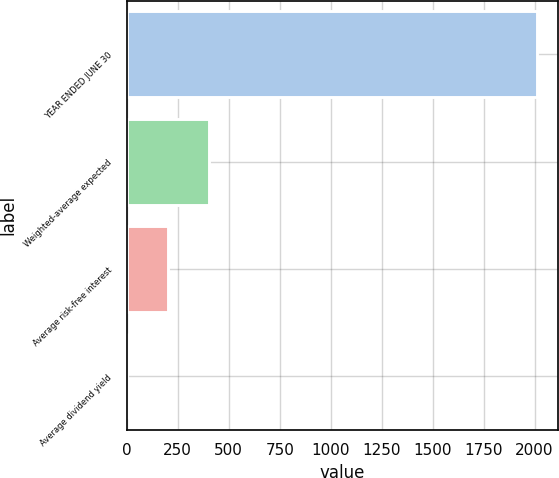Convert chart to OTSL. <chart><loc_0><loc_0><loc_500><loc_500><bar_chart><fcel>YEAR ENDED JUNE 30<fcel>Weighted-average expected<fcel>Average risk-free interest<fcel>Average dividend yield<nl><fcel>2012<fcel>403.2<fcel>202.1<fcel>1<nl></chart> 